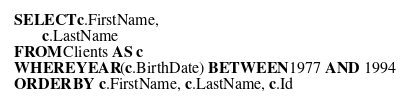Convert code to text. <code><loc_0><loc_0><loc_500><loc_500><_SQL_>SELECT c.FirstName,
       c.LastName
FROM Clients AS c
WHERE YEAR(c.BirthDate) BETWEEN 1977 AND 1994
ORDER BY c.FirstName, c.LastName, c.Id</code> 